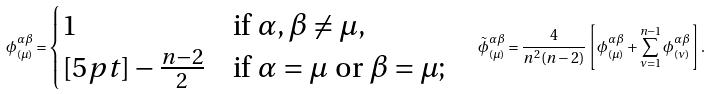Convert formula to latex. <formula><loc_0><loc_0><loc_500><loc_500>\phi ^ { \alpha \beta } _ { ( \mu ) } = \begin{cases} 1 & \text {if $\alpha,\beta\not=\mu$} , \\ [ 5 p t ] - \frac { n - 2 } { 2 } & \text {if $\alpha=\mu$ or $\beta=\mu$} ; \end{cases} \quad { \tilde { \phi } } ^ { \alpha \beta } _ { ( \mu ) } = \frac { 4 } { n ^ { 2 } ( n - 2 ) } \left [ \phi ^ { \alpha \beta } _ { ( \mu ) } + \sum _ { \nu = 1 } ^ { n - 1 } \phi ^ { \alpha \beta } _ { ( \nu ) } \right ] .</formula> 